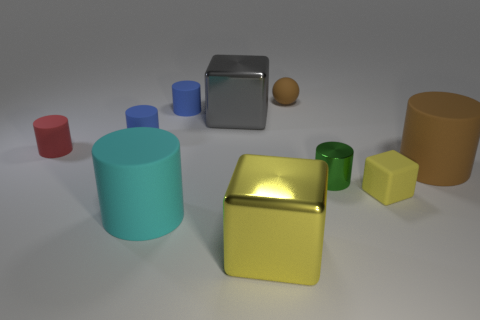What might be the purpose of arranging these objects like this? This arrangement appears to be deliberately staged for educational or demonstrative purposes, possibly to illustrate the concepts of geometry, color theory, or lighting in photography. The clean background and even spacing allow each object to be distinctly observed. Is there a pattern to the arrangement of these objects? While there doesn't seem to be a strict pattern, the objects are placed with ample space between them, which could suggest an intentional design to highlight each item's individual characteristics without distraction or overlap. 